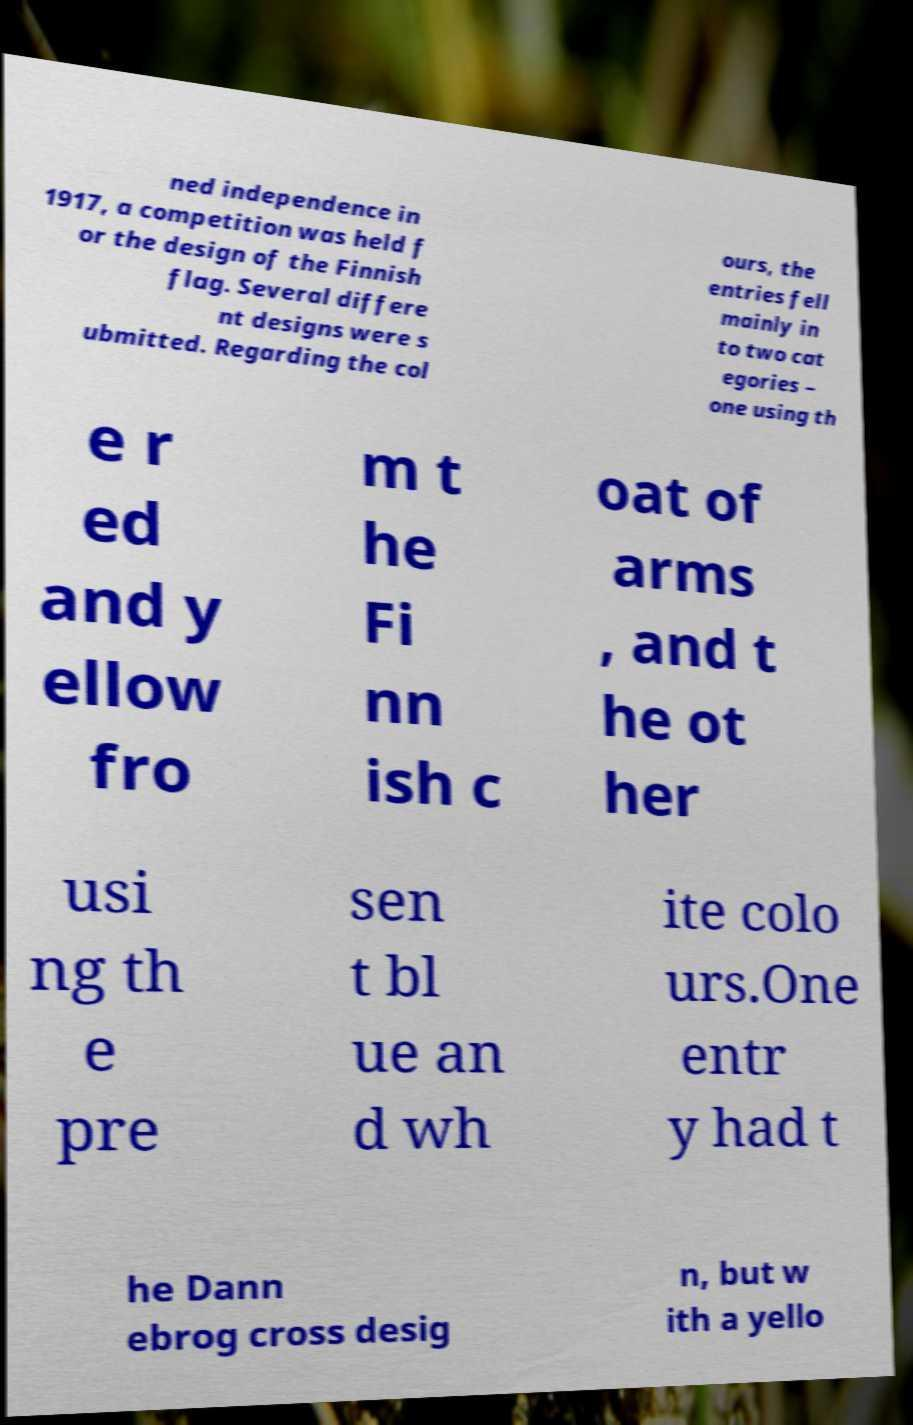Could you assist in decoding the text presented in this image and type it out clearly? ned independence in 1917, a competition was held f or the design of the Finnish flag. Several differe nt designs were s ubmitted. Regarding the col ours, the entries fell mainly in to two cat egories – one using th e r ed and y ellow fro m t he Fi nn ish c oat of arms , and t he ot her usi ng th e pre sen t bl ue an d wh ite colo urs.One entr y had t he Dann ebrog cross desig n, but w ith a yello 